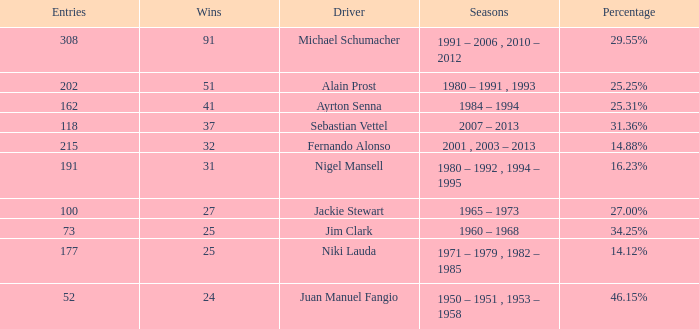Which season did jackie stewart enter with entries less than 215? 1965 – 1973. 